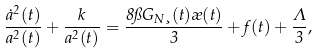Convert formula to latex. <formula><loc_0><loc_0><loc_500><loc_500>\frac { \dot { a } ^ { 2 } ( t ) } { a ^ { 2 } ( t ) } + \frac { k } { a ^ { 2 } ( t ) } = \frac { 8 \pi G _ { N } \xi ( t ) \rho ( t ) } { 3 } + f ( t ) + \frac { \Lambda } { 3 } ,</formula> 